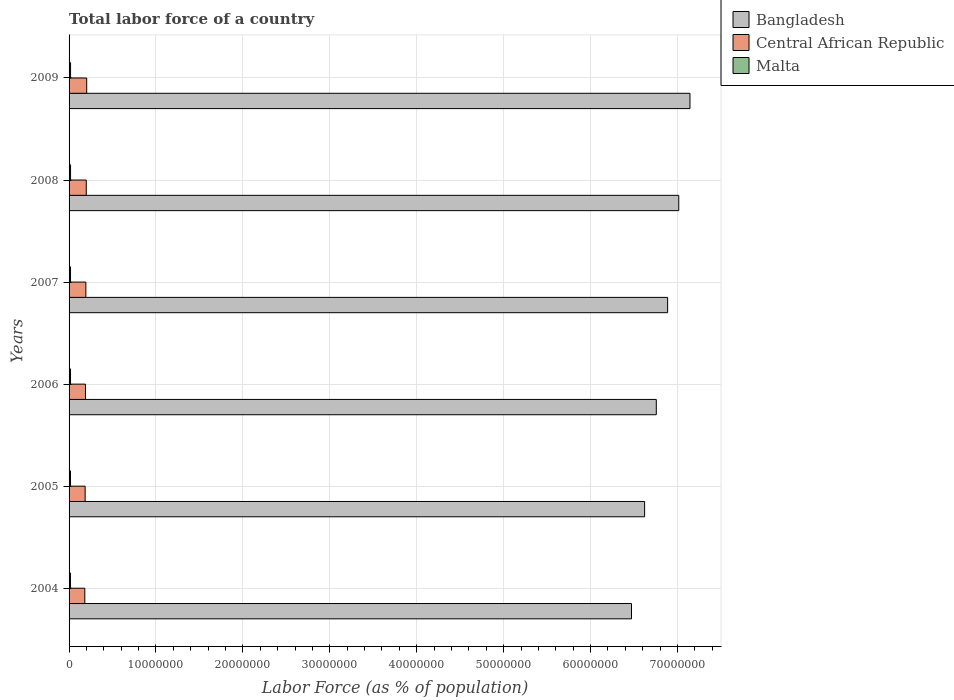How many groups of bars are there?
Offer a terse response. 6. Are the number of bars per tick equal to the number of legend labels?
Offer a terse response. Yes. What is the label of the 4th group of bars from the top?
Keep it short and to the point. 2006. What is the percentage of labor force in Bangladesh in 2004?
Keep it short and to the point. 6.47e+07. Across all years, what is the maximum percentage of labor force in Malta?
Give a very brief answer. 1.72e+05. Across all years, what is the minimum percentage of labor force in Central African Republic?
Offer a terse response. 1.81e+06. In which year was the percentage of labor force in Central African Republic maximum?
Provide a short and direct response. 2009. What is the total percentage of labor force in Malta in the graph?
Provide a succinct answer. 9.97e+05. What is the difference between the percentage of labor force in Bangladesh in 2005 and that in 2007?
Your answer should be very brief. -2.65e+06. What is the difference between the percentage of labor force in Bangladesh in 2004 and the percentage of labor force in Malta in 2008?
Offer a terse response. 6.45e+07. What is the average percentage of labor force in Central African Republic per year?
Give a very brief answer. 1.91e+06. In the year 2007, what is the difference between the percentage of labor force in Malta and percentage of labor force in Central African Republic?
Give a very brief answer. -1.76e+06. In how many years, is the percentage of labor force in Central African Republic greater than 56000000 %?
Provide a succinct answer. 0. What is the ratio of the percentage of labor force in Central African Republic in 2007 to that in 2009?
Offer a very short reply. 0.95. Is the difference between the percentage of labor force in Malta in 2004 and 2005 greater than the difference between the percentage of labor force in Central African Republic in 2004 and 2005?
Offer a very short reply. Yes. What is the difference between the highest and the second highest percentage of labor force in Bangladesh?
Give a very brief answer. 1.29e+06. What is the difference between the highest and the lowest percentage of labor force in Malta?
Make the answer very short. 1.28e+04. Is the sum of the percentage of labor force in Malta in 2005 and 2009 greater than the maximum percentage of labor force in Bangladesh across all years?
Your answer should be compact. No. What does the 3rd bar from the bottom in 2005 represents?
Your answer should be very brief. Malta. Is it the case that in every year, the sum of the percentage of labor force in Malta and percentage of labor force in Central African Republic is greater than the percentage of labor force in Bangladesh?
Offer a very short reply. No. How many bars are there?
Your answer should be very brief. 18. What is the difference between two consecutive major ticks on the X-axis?
Ensure brevity in your answer.  1.00e+07. Does the graph contain any zero values?
Ensure brevity in your answer.  No. Does the graph contain grids?
Your answer should be very brief. Yes. How many legend labels are there?
Offer a very short reply. 3. What is the title of the graph?
Offer a very short reply. Total labor force of a country. Does "Cote d'Ivoire" appear as one of the legend labels in the graph?
Your answer should be very brief. No. What is the label or title of the X-axis?
Ensure brevity in your answer.  Labor Force (as % of population). What is the Labor Force (as % of population) in Bangladesh in 2004?
Make the answer very short. 6.47e+07. What is the Labor Force (as % of population) in Central African Republic in 2004?
Provide a short and direct response. 1.81e+06. What is the Labor Force (as % of population) of Malta in 2004?
Provide a short and direct response. 1.60e+05. What is the Labor Force (as % of population) of Bangladesh in 2005?
Offer a very short reply. 6.62e+07. What is the Labor Force (as % of population) in Central African Republic in 2005?
Your response must be concise. 1.85e+06. What is the Labor Force (as % of population) of Malta in 2005?
Provide a short and direct response. 1.63e+05. What is the Labor Force (as % of population) in Bangladesh in 2006?
Your response must be concise. 6.76e+07. What is the Labor Force (as % of population) of Central African Republic in 2006?
Offer a terse response. 1.89e+06. What is the Labor Force (as % of population) of Malta in 2006?
Offer a very short reply. 1.64e+05. What is the Labor Force (as % of population) of Bangladesh in 2007?
Provide a succinct answer. 6.89e+07. What is the Labor Force (as % of population) of Central African Republic in 2007?
Ensure brevity in your answer.  1.93e+06. What is the Labor Force (as % of population) of Malta in 2007?
Your answer should be very brief. 1.68e+05. What is the Labor Force (as % of population) of Bangladesh in 2008?
Offer a very short reply. 7.01e+07. What is the Labor Force (as % of population) in Central African Republic in 2008?
Your response must be concise. 1.98e+06. What is the Labor Force (as % of population) in Malta in 2008?
Your answer should be very brief. 1.70e+05. What is the Labor Force (as % of population) in Bangladesh in 2009?
Ensure brevity in your answer.  7.14e+07. What is the Labor Force (as % of population) of Central African Republic in 2009?
Offer a terse response. 2.03e+06. What is the Labor Force (as % of population) in Malta in 2009?
Your response must be concise. 1.72e+05. Across all years, what is the maximum Labor Force (as % of population) in Bangladesh?
Your answer should be compact. 7.14e+07. Across all years, what is the maximum Labor Force (as % of population) of Central African Republic?
Give a very brief answer. 2.03e+06. Across all years, what is the maximum Labor Force (as % of population) in Malta?
Keep it short and to the point. 1.72e+05. Across all years, what is the minimum Labor Force (as % of population) in Bangladesh?
Provide a succinct answer. 6.47e+07. Across all years, what is the minimum Labor Force (as % of population) in Central African Republic?
Offer a very short reply. 1.81e+06. Across all years, what is the minimum Labor Force (as % of population) in Malta?
Make the answer very short. 1.60e+05. What is the total Labor Force (as % of population) in Bangladesh in the graph?
Make the answer very short. 4.09e+08. What is the total Labor Force (as % of population) of Central African Republic in the graph?
Offer a terse response. 1.15e+07. What is the total Labor Force (as % of population) in Malta in the graph?
Offer a very short reply. 9.97e+05. What is the difference between the Labor Force (as % of population) in Bangladesh in 2004 and that in 2005?
Provide a succinct answer. -1.51e+06. What is the difference between the Labor Force (as % of population) of Central African Republic in 2004 and that in 2005?
Give a very brief answer. -3.83e+04. What is the difference between the Labor Force (as % of population) in Malta in 2004 and that in 2005?
Give a very brief answer. -3392. What is the difference between the Labor Force (as % of population) in Bangladesh in 2004 and that in 2006?
Provide a short and direct response. -2.85e+06. What is the difference between the Labor Force (as % of population) of Central African Republic in 2004 and that in 2006?
Offer a very short reply. -7.64e+04. What is the difference between the Labor Force (as % of population) in Malta in 2004 and that in 2006?
Ensure brevity in your answer.  -4594. What is the difference between the Labor Force (as % of population) in Bangladesh in 2004 and that in 2007?
Make the answer very short. -4.15e+06. What is the difference between the Labor Force (as % of population) in Central African Republic in 2004 and that in 2007?
Your response must be concise. -1.20e+05. What is the difference between the Labor Force (as % of population) in Malta in 2004 and that in 2007?
Provide a short and direct response. -8226. What is the difference between the Labor Force (as % of population) in Bangladesh in 2004 and that in 2008?
Make the answer very short. -5.44e+06. What is the difference between the Labor Force (as % of population) in Central African Republic in 2004 and that in 2008?
Offer a terse response. -1.67e+05. What is the difference between the Labor Force (as % of population) of Malta in 2004 and that in 2008?
Provide a short and direct response. -1.06e+04. What is the difference between the Labor Force (as % of population) of Bangladesh in 2004 and that in 2009?
Provide a succinct answer. -6.73e+06. What is the difference between the Labor Force (as % of population) of Central African Republic in 2004 and that in 2009?
Your answer should be very brief. -2.17e+05. What is the difference between the Labor Force (as % of population) in Malta in 2004 and that in 2009?
Give a very brief answer. -1.28e+04. What is the difference between the Labor Force (as % of population) of Bangladesh in 2005 and that in 2006?
Your answer should be compact. -1.34e+06. What is the difference between the Labor Force (as % of population) in Central African Republic in 2005 and that in 2006?
Provide a short and direct response. -3.81e+04. What is the difference between the Labor Force (as % of population) of Malta in 2005 and that in 2006?
Offer a terse response. -1202. What is the difference between the Labor Force (as % of population) of Bangladesh in 2005 and that in 2007?
Make the answer very short. -2.65e+06. What is the difference between the Labor Force (as % of population) of Central African Republic in 2005 and that in 2007?
Give a very brief answer. -8.20e+04. What is the difference between the Labor Force (as % of population) in Malta in 2005 and that in 2007?
Your response must be concise. -4834. What is the difference between the Labor Force (as % of population) of Bangladesh in 2005 and that in 2008?
Keep it short and to the point. -3.93e+06. What is the difference between the Labor Force (as % of population) in Central African Republic in 2005 and that in 2008?
Make the answer very short. -1.29e+05. What is the difference between the Labor Force (as % of population) in Malta in 2005 and that in 2008?
Offer a terse response. -7177. What is the difference between the Labor Force (as % of population) of Bangladesh in 2005 and that in 2009?
Ensure brevity in your answer.  -5.22e+06. What is the difference between the Labor Force (as % of population) in Central African Republic in 2005 and that in 2009?
Your answer should be compact. -1.79e+05. What is the difference between the Labor Force (as % of population) of Malta in 2005 and that in 2009?
Keep it short and to the point. -9363. What is the difference between the Labor Force (as % of population) in Bangladesh in 2006 and that in 2007?
Give a very brief answer. -1.30e+06. What is the difference between the Labor Force (as % of population) in Central African Republic in 2006 and that in 2007?
Make the answer very short. -4.39e+04. What is the difference between the Labor Force (as % of population) in Malta in 2006 and that in 2007?
Your response must be concise. -3632. What is the difference between the Labor Force (as % of population) in Bangladesh in 2006 and that in 2008?
Offer a terse response. -2.58e+06. What is the difference between the Labor Force (as % of population) of Central African Republic in 2006 and that in 2008?
Your answer should be compact. -9.08e+04. What is the difference between the Labor Force (as % of population) of Malta in 2006 and that in 2008?
Your answer should be very brief. -5975. What is the difference between the Labor Force (as % of population) in Bangladesh in 2006 and that in 2009?
Make the answer very short. -3.87e+06. What is the difference between the Labor Force (as % of population) in Central African Republic in 2006 and that in 2009?
Provide a succinct answer. -1.41e+05. What is the difference between the Labor Force (as % of population) of Malta in 2006 and that in 2009?
Your response must be concise. -8161. What is the difference between the Labor Force (as % of population) of Bangladesh in 2007 and that in 2008?
Your answer should be compact. -1.28e+06. What is the difference between the Labor Force (as % of population) of Central African Republic in 2007 and that in 2008?
Provide a short and direct response. -4.70e+04. What is the difference between the Labor Force (as % of population) of Malta in 2007 and that in 2008?
Keep it short and to the point. -2343. What is the difference between the Labor Force (as % of population) of Bangladesh in 2007 and that in 2009?
Offer a very short reply. -2.57e+06. What is the difference between the Labor Force (as % of population) of Central African Republic in 2007 and that in 2009?
Your answer should be very brief. -9.67e+04. What is the difference between the Labor Force (as % of population) of Malta in 2007 and that in 2009?
Offer a very short reply. -4529. What is the difference between the Labor Force (as % of population) in Bangladesh in 2008 and that in 2009?
Give a very brief answer. -1.29e+06. What is the difference between the Labor Force (as % of population) in Central African Republic in 2008 and that in 2009?
Ensure brevity in your answer.  -4.98e+04. What is the difference between the Labor Force (as % of population) of Malta in 2008 and that in 2009?
Provide a short and direct response. -2186. What is the difference between the Labor Force (as % of population) in Bangladesh in 2004 and the Labor Force (as % of population) in Central African Republic in 2005?
Provide a succinct answer. 6.29e+07. What is the difference between the Labor Force (as % of population) in Bangladesh in 2004 and the Labor Force (as % of population) in Malta in 2005?
Provide a succinct answer. 6.45e+07. What is the difference between the Labor Force (as % of population) of Central African Republic in 2004 and the Labor Force (as % of population) of Malta in 2005?
Your answer should be very brief. 1.65e+06. What is the difference between the Labor Force (as % of population) of Bangladesh in 2004 and the Labor Force (as % of population) of Central African Republic in 2006?
Your answer should be very brief. 6.28e+07. What is the difference between the Labor Force (as % of population) of Bangladesh in 2004 and the Labor Force (as % of population) of Malta in 2006?
Give a very brief answer. 6.45e+07. What is the difference between the Labor Force (as % of population) in Central African Republic in 2004 and the Labor Force (as % of population) in Malta in 2006?
Your answer should be very brief. 1.65e+06. What is the difference between the Labor Force (as % of population) in Bangladesh in 2004 and the Labor Force (as % of population) in Central African Republic in 2007?
Offer a very short reply. 6.28e+07. What is the difference between the Labor Force (as % of population) of Bangladesh in 2004 and the Labor Force (as % of population) of Malta in 2007?
Your answer should be very brief. 6.45e+07. What is the difference between the Labor Force (as % of population) in Central African Republic in 2004 and the Labor Force (as % of population) in Malta in 2007?
Ensure brevity in your answer.  1.64e+06. What is the difference between the Labor Force (as % of population) of Bangladesh in 2004 and the Labor Force (as % of population) of Central African Republic in 2008?
Your response must be concise. 6.27e+07. What is the difference between the Labor Force (as % of population) of Bangladesh in 2004 and the Labor Force (as % of population) of Malta in 2008?
Provide a succinct answer. 6.45e+07. What is the difference between the Labor Force (as % of population) of Central African Republic in 2004 and the Labor Force (as % of population) of Malta in 2008?
Offer a terse response. 1.64e+06. What is the difference between the Labor Force (as % of population) in Bangladesh in 2004 and the Labor Force (as % of population) in Central African Republic in 2009?
Provide a succinct answer. 6.27e+07. What is the difference between the Labor Force (as % of population) in Bangladesh in 2004 and the Labor Force (as % of population) in Malta in 2009?
Ensure brevity in your answer.  6.45e+07. What is the difference between the Labor Force (as % of population) in Central African Republic in 2004 and the Labor Force (as % of population) in Malta in 2009?
Your answer should be very brief. 1.64e+06. What is the difference between the Labor Force (as % of population) in Bangladesh in 2005 and the Labor Force (as % of population) in Central African Republic in 2006?
Offer a very short reply. 6.43e+07. What is the difference between the Labor Force (as % of population) in Bangladesh in 2005 and the Labor Force (as % of population) in Malta in 2006?
Your response must be concise. 6.61e+07. What is the difference between the Labor Force (as % of population) of Central African Republic in 2005 and the Labor Force (as % of population) of Malta in 2006?
Give a very brief answer. 1.69e+06. What is the difference between the Labor Force (as % of population) in Bangladesh in 2005 and the Labor Force (as % of population) in Central African Republic in 2007?
Provide a short and direct response. 6.43e+07. What is the difference between the Labor Force (as % of population) of Bangladesh in 2005 and the Labor Force (as % of population) of Malta in 2007?
Ensure brevity in your answer.  6.60e+07. What is the difference between the Labor Force (as % of population) in Central African Republic in 2005 and the Labor Force (as % of population) in Malta in 2007?
Keep it short and to the point. 1.68e+06. What is the difference between the Labor Force (as % of population) of Bangladesh in 2005 and the Labor Force (as % of population) of Central African Republic in 2008?
Offer a terse response. 6.42e+07. What is the difference between the Labor Force (as % of population) in Bangladesh in 2005 and the Labor Force (as % of population) in Malta in 2008?
Offer a terse response. 6.60e+07. What is the difference between the Labor Force (as % of population) of Central African Republic in 2005 and the Labor Force (as % of population) of Malta in 2008?
Provide a succinct answer. 1.68e+06. What is the difference between the Labor Force (as % of population) in Bangladesh in 2005 and the Labor Force (as % of population) in Central African Republic in 2009?
Give a very brief answer. 6.42e+07. What is the difference between the Labor Force (as % of population) of Bangladesh in 2005 and the Labor Force (as % of population) of Malta in 2009?
Make the answer very short. 6.60e+07. What is the difference between the Labor Force (as % of population) of Central African Republic in 2005 and the Labor Force (as % of population) of Malta in 2009?
Your answer should be compact. 1.68e+06. What is the difference between the Labor Force (as % of population) in Bangladesh in 2006 and the Labor Force (as % of population) in Central African Republic in 2007?
Provide a short and direct response. 6.56e+07. What is the difference between the Labor Force (as % of population) of Bangladesh in 2006 and the Labor Force (as % of population) of Malta in 2007?
Offer a very short reply. 6.74e+07. What is the difference between the Labor Force (as % of population) in Central African Republic in 2006 and the Labor Force (as % of population) in Malta in 2007?
Your answer should be very brief. 1.72e+06. What is the difference between the Labor Force (as % of population) of Bangladesh in 2006 and the Labor Force (as % of population) of Central African Republic in 2008?
Your response must be concise. 6.56e+07. What is the difference between the Labor Force (as % of population) of Bangladesh in 2006 and the Labor Force (as % of population) of Malta in 2008?
Your response must be concise. 6.74e+07. What is the difference between the Labor Force (as % of population) of Central African Republic in 2006 and the Labor Force (as % of population) of Malta in 2008?
Offer a terse response. 1.72e+06. What is the difference between the Labor Force (as % of population) in Bangladesh in 2006 and the Labor Force (as % of population) in Central African Republic in 2009?
Offer a very short reply. 6.55e+07. What is the difference between the Labor Force (as % of population) of Bangladesh in 2006 and the Labor Force (as % of population) of Malta in 2009?
Your answer should be very brief. 6.74e+07. What is the difference between the Labor Force (as % of population) of Central African Republic in 2006 and the Labor Force (as % of population) of Malta in 2009?
Offer a terse response. 1.72e+06. What is the difference between the Labor Force (as % of population) in Bangladesh in 2007 and the Labor Force (as % of population) in Central African Republic in 2008?
Make the answer very short. 6.69e+07. What is the difference between the Labor Force (as % of population) of Bangladesh in 2007 and the Labor Force (as % of population) of Malta in 2008?
Your answer should be very brief. 6.87e+07. What is the difference between the Labor Force (as % of population) in Central African Republic in 2007 and the Labor Force (as % of population) in Malta in 2008?
Provide a short and direct response. 1.76e+06. What is the difference between the Labor Force (as % of population) in Bangladesh in 2007 and the Labor Force (as % of population) in Central African Republic in 2009?
Offer a very short reply. 6.68e+07. What is the difference between the Labor Force (as % of population) in Bangladesh in 2007 and the Labor Force (as % of population) in Malta in 2009?
Your response must be concise. 6.87e+07. What is the difference between the Labor Force (as % of population) in Central African Republic in 2007 and the Labor Force (as % of population) in Malta in 2009?
Provide a short and direct response. 1.76e+06. What is the difference between the Labor Force (as % of population) of Bangladesh in 2008 and the Labor Force (as % of population) of Central African Republic in 2009?
Make the answer very short. 6.81e+07. What is the difference between the Labor Force (as % of population) of Bangladesh in 2008 and the Labor Force (as % of population) of Malta in 2009?
Provide a succinct answer. 7.00e+07. What is the difference between the Labor Force (as % of population) of Central African Republic in 2008 and the Labor Force (as % of population) of Malta in 2009?
Offer a terse response. 1.81e+06. What is the average Labor Force (as % of population) of Bangladesh per year?
Provide a succinct answer. 6.82e+07. What is the average Labor Force (as % of population) of Central African Republic per year?
Provide a succinct answer. 1.91e+06. What is the average Labor Force (as % of population) of Malta per year?
Offer a very short reply. 1.66e+05. In the year 2004, what is the difference between the Labor Force (as % of population) of Bangladesh and Labor Force (as % of population) of Central African Republic?
Your answer should be compact. 6.29e+07. In the year 2004, what is the difference between the Labor Force (as % of population) of Bangladesh and Labor Force (as % of population) of Malta?
Provide a short and direct response. 6.45e+07. In the year 2004, what is the difference between the Labor Force (as % of population) in Central African Republic and Labor Force (as % of population) in Malta?
Your answer should be compact. 1.65e+06. In the year 2005, what is the difference between the Labor Force (as % of population) in Bangladesh and Labor Force (as % of population) in Central African Republic?
Keep it short and to the point. 6.44e+07. In the year 2005, what is the difference between the Labor Force (as % of population) in Bangladesh and Labor Force (as % of population) in Malta?
Your answer should be very brief. 6.61e+07. In the year 2005, what is the difference between the Labor Force (as % of population) in Central African Republic and Labor Force (as % of population) in Malta?
Your answer should be compact. 1.69e+06. In the year 2006, what is the difference between the Labor Force (as % of population) in Bangladesh and Labor Force (as % of population) in Central African Republic?
Your answer should be very brief. 6.57e+07. In the year 2006, what is the difference between the Labor Force (as % of population) of Bangladesh and Labor Force (as % of population) of Malta?
Offer a terse response. 6.74e+07. In the year 2006, what is the difference between the Labor Force (as % of population) in Central African Republic and Labor Force (as % of population) in Malta?
Offer a terse response. 1.72e+06. In the year 2007, what is the difference between the Labor Force (as % of population) in Bangladesh and Labor Force (as % of population) in Central African Republic?
Offer a very short reply. 6.69e+07. In the year 2007, what is the difference between the Labor Force (as % of population) of Bangladesh and Labor Force (as % of population) of Malta?
Offer a very short reply. 6.87e+07. In the year 2007, what is the difference between the Labor Force (as % of population) in Central African Republic and Labor Force (as % of population) in Malta?
Provide a short and direct response. 1.76e+06. In the year 2008, what is the difference between the Labor Force (as % of population) of Bangladesh and Labor Force (as % of population) of Central African Republic?
Give a very brief answer. 6.82e+07. In the year 2008, what is the difference between the Labor Force (as % of population) of Bangladesh and Labor Force (as % of population) of Malta?
Your response must be concise. 7.00e+07. In the year 2008, what is the difference between the Labor Force (as % of population) in Central African Republic and Labor Force (as % of population) in Malta?
Give a very brief answer. 1.81e+06. In the year 2009, what is the difference between the Labor Force (as % of population) of Bangladesh and Labor Force (as % of population) of Central African Republic?
Provide a short and direct response. 6.94e+07. In the year 2009, what is the difference between the Labor Force (as % of population) in Bangladesh and Labor Force (as % of population) in Malta?
Offer a terse response. 7.13e+07. In the year 2009, what is the difference between the Labor Force (as % of population) of Central African Republic and Labor Force (as % of population) of Malta?
Make the answer very short. 1.86e+06. What is the ratio of the Labor Force (as % of population) of Bangladesh in 2004 to that in 2005?
Give a very brief answer. 0.98. What is the ratio of the Labor Force (as % of population) in Central African Republic in 2004 to that in 2005?
Make the answer very short. 0.98. What is the ratio of the Labor Force (as % of population) in Malta in 2004 to that in 2005?
Give a very brief answer. 0.98. What is the ratio of the Labor Force (as % of population) in Bangladesh in 2004 to that in 2006?
Your answer should be very brief. 0.96. What is the ratio of the Labor Force (as % of population) of Central African Republic in 2004 to that in 2006?
Your answer should be very brief. 0.96. What is the ratio of the Labor Force (as % of population) in Bangladesh in 2004 to that in 2007?
Ensure brevity in your answer.  0.94. What is the ratio of the Labor Force (as % of population) in Central African Republic in 2004 to that in 2007?
Provide a short and direct response. 0.94. What is the ratio of the Labor Force (as % of population) of Malta in 2004 to that in 2007?
Provide a succinct answer. 0.95. What is the ratio of the Labor Force (as % of population) of Bangladesh in 2004 to that in 2008?
Ensure brevity in your answer.  0.92. What is the ratio of the Labor Force (as % of population) of Central African Republic in 2004 to that in 2008?
Provide a succinct answer. 0.92. What is the ratio of the Labor Force (as % of population) of Malta in 2004 to that in 2008?
Keep it short and to the point. 0.94. What is the ratio of the Labor Force (as % of population) of Bangladesh in 2004 to that in 2009?
Offer a very short reply. 0.91. What is the ratio of the Labor Force (as % of population) in Central African Republic in 2004 to that in 2009?
Provide a short and direct response. 0.89. What is the ratio of the Labor Force (as % of population) of Malta in 2004 to that in 2009?
Provide a short and direct response. 0.93. What is the ratio of the Labor Force (as % of population) in Bangladesh in 2005 to that in 2006?
Provide a short and direct response. 0.98. What is the ratio of the Labor Force (as % of population) of Central African Republic in 2005 to that in 2006?
Offer a very short reply. 0.98. What is the ratio of the Labor Force (as % of population) of Malta in 2005 to that in 2006?
Offer a very short reply. 0.99. What is the ratio of the Labor Force (as % of population) in Bangladesh in 2005 to that in 2007?
Provide a succinct answer. 0.96. What is the ratio of the Labor Force (as % of population) of Central African Republic in 2005 to that in 2007?
Ensure brevity in your answer.  0.96. What is the ratio of the Labor Force (as % of population) of Malta in 2005 to that in 2007?
Your answer should be compact. 0.97. What is the ratio of the Labor Force (as % of population) in Bangladesh in 2005 to that in 2008?
Offer a terse response. 0.94. What is the ratio of the Labor Force (as % of population) in Central African Republic in 2005 to that in 2008?
Provide a succinct answer. 0.93. What is the ratio of the Labor Force (as % of population) in Malta in 2005 to that in 2008?
Your response must be concise. 0.96. What is the ratio of the Labor Force (as % of population) of Bangladesh in 2005 to that in 2009?
Provide a succinct answer. 0.93. What is the ratio of the Labor Force (as % of population) of Central African Republic in 2005 to that in 2009?
Offer a terse response. 0.91. What is the ratio of the Labor Force (as % of population) of Malta in 2005 to that in 2009?
Your answer should be very brief. 0.95. What is the ratio of the Labor Force (as % of population) of Bangladesh in 2006 to that in 2007?
Provide a succinct answer. 0.98. What is the ratio of the Labor Force (as % of population) of Central African Republic in 2006 to that in 2007?
Your answer should be very brief. 0.98. What is the ratio of the Labor Force (as % of population) of Malta in 2006 to that in 2007?
Your response must be concise. 0.98. What is the ratio of the Labor Force (as % of population) in Bangladesh in 2006 to that in 2008?
Provide a succinct answer. 0.96. What is the ratio of the Labor Force (as % of population) in Central African Republic in 2006 to that in 2008?
Ensure brevity in your answer.  0.95. What is the ratio of the Labor Force (as % of population) in Malta in 2006 to that in 2008?
Your answer should be very brief. 0.96. What is the ratio of the Labor Force (as % of population) of Bangladesh in 2006 to that in 2009?
Your answer should be very brief. 0.95. What is the ratio of the Labor Force (as % of population) of Central African Republic in 2006 to that in 2009?
Give a very brief answer. 0.93. What is the ratio of the Labor Force (as % of population) of Malta in 2006 to that in 2009?
Offer a very short reply. 0.95. What is the ratio of the Labor Force (as % of population) of Bangladesh in 2007 to that in 2008?
Provide a succinct answer. 0.98. What is the ratio of the Labor Force (as % of population) in Central African Republic in 2007 to that in 2008?
Offer a terse response. 0.98. What is the ratio of the Labor Force (as % of population) in Malta in 2007 to that in 2008?
Offer a very short reply. 0.99. What is the ratio of the Labor Force (as % of population) of Bangladesh in 2007 to that in 2009?
Your response must be concise. 0.96. What is the ratio of the Labor Force (as % of population) in Central African Republic in 2007 to that in 2009?
Provide a short and direct response. 0.95. What is the ratio of the Labor Force (as % of population) in Malta in 2007 to that in 2009?
Your answer should be compact. 0.97. What is the ratio of the Labor Force (as % of population) of Central African Republic in 2008 to that in 2009?
Give a very brief answer. 0.98. What is the ratio of the Labor Force (as % of population) of Malta in 2008 to that in 2009?
Provide a short and direct response. 0.99. What is the difference between the highest and the second highest Labor Force (as % of population) in Bangladesh?
Ensure brevity in your answer.  1.29e+06. What is the difference between the highest and the second highest Labor Force (as % of population) in Central African Republic?
Provide a short and direct response. 4.98e+04. What is the difference between the highest and the second highest Labor Force (as % of population) of Malta?
Your answer should be compact. 2186. What is the difference between the highest and the lowest Labor Force (as % of population) of Bangladesh?
Your answer should be compact. 6.73e+06. What is the difference between the highest and the lowest Labor Force (as % of population) in Central African Republic?
Your response must be concise. 2.17e+05. What is the difference between the highest and the lowest Labor Force (as % of population) in Malta?
Keep it short and to the point. 1.28e+04. 